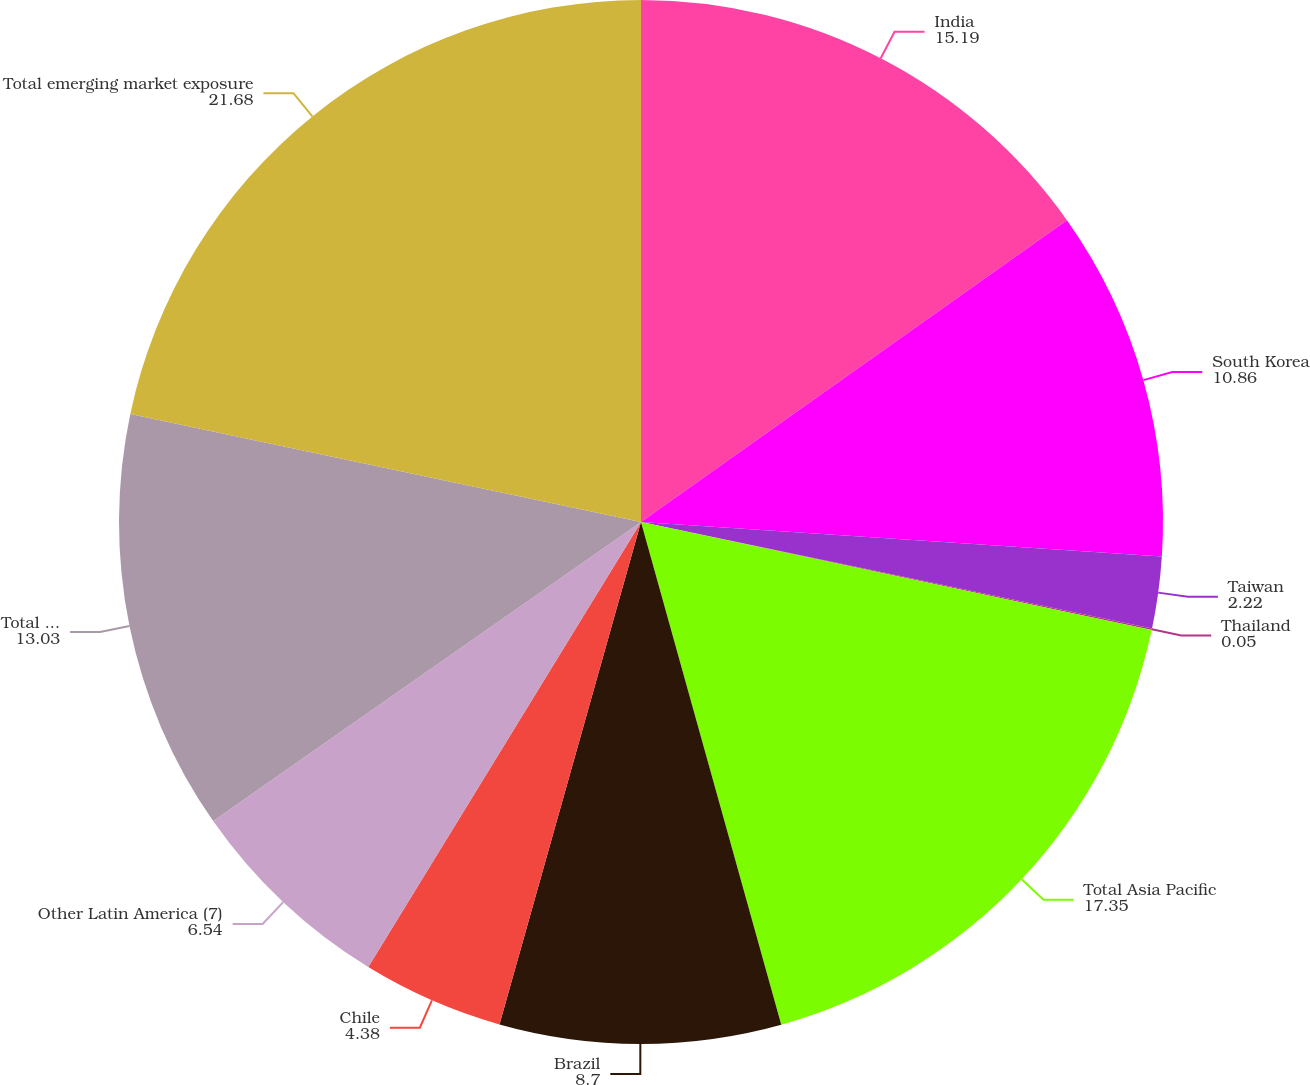<chart> <loc_0><loc_0><loc_500><loc_500><pie_chart><fcel>India<fcel>South Korea<fcel>Taiwan<fcel>Thailand<fcel>Total Asia Pacific<fcel>Brazil<fcel>Chile<fcel>Other Latin America (7)<fcel>Total Latin America<fcel>Total emerging market exposure<nl><fcel>15.19%<fcel>10.86%<fcel>2.22%<fcel>0.05%<fcel>17.35%<fcel>8.7%<fcel>4.38%<fcel>6.54%<fcel>13.03%<fcel>21.68%<nl></chart> 